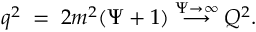Convert formula to latex. <formula><loc_0><loc_0><loc_500><loc_500>q ^ { 2 } \, = \, 2 m ^ { 2 } ( \Psi + 1 ) \stackrel { \Psi \to \infty } { \longrightarrow } Q ^ { 2 } .</formula> 